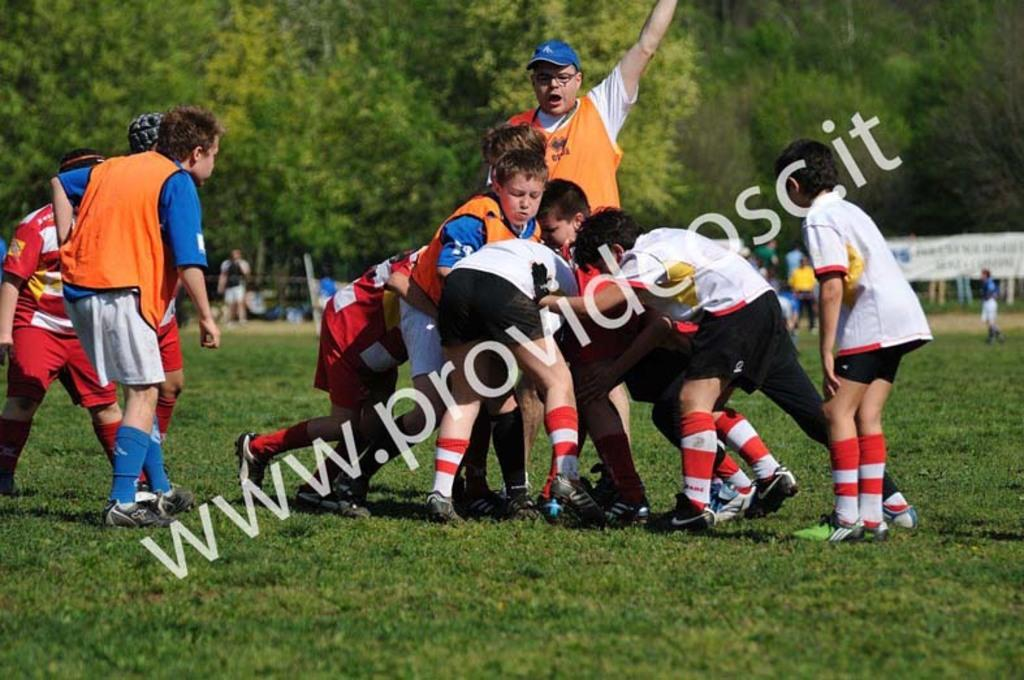How many people are in the image? There is a group of people in the image, but the exact number cannot be determined from the provided facts. What is the ground covered with in the image? The ground is covered with grass in the image. What type of vegetation can be seen in the image? There are trees in the image. What additional items are present in the image? There are banners in the image. How many tickets are visible in the image? There is no mention of tickets in the provided facts, so we cannot determine if any are visible in the image. Are there any badges being worn by the people in the image? There is no mention of badges in the provided facts, so we cannot determine if any are being worn by the people in the image. 